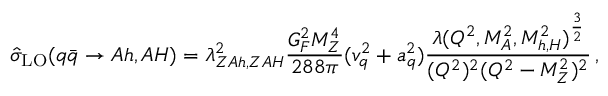Convert formula to latex. <formula><loc_0><loc_0><loc_500><loc_500>\hat { \sigma } _ { L O } ( q \bar { q } \to A h , A H ) = \lambda _ { Z A h , Z A H } ^ { 2 } \frac { G _ { F } ^ { 2 } M _ { Z } ^ { 4 } } { 2 8 8 \pi } ( v _ { q } ^ { 2 } + a _ { q } ^ { 2 } ) \frac { \lambda ( Q ^ { 2 } , M _ { A } ^ { 2 } , M _ { h , H } ^ { 2 } ) ^ { \frac { 3 } { 2 } } } { ( Q ^ { 2 } ) ^ { 2 } ( Q ^ { 2 } - M _ { Z } ^ { 2 } ) ^ { 2 } } \, ,</formula> 